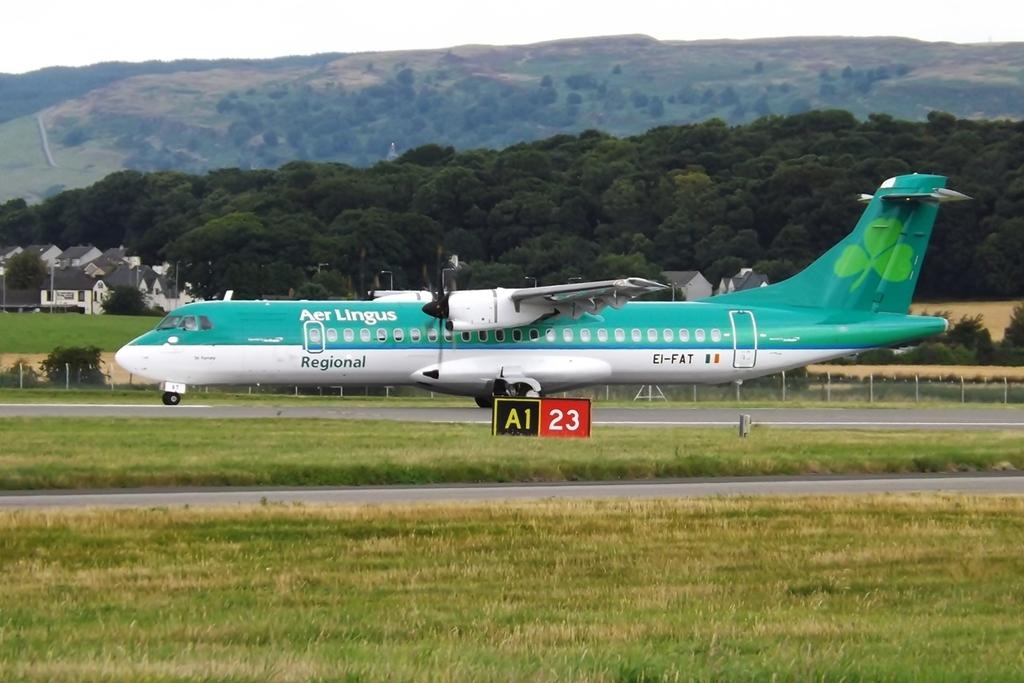<image>
Create a compact narrative representing the image presented. A large green Air Lingus Airplane with a backdrop of mountains. 